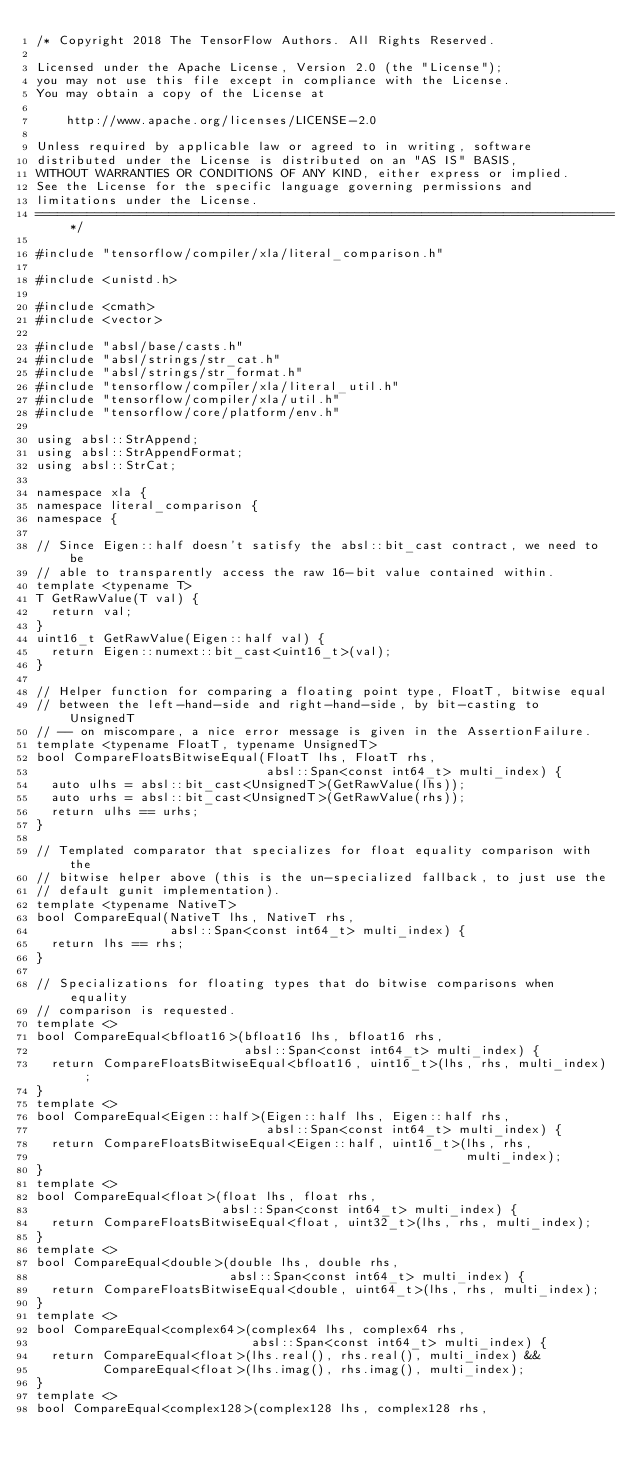<code> <loc_0><loc_0><loc_500><loc_500><_C++_>/* Copyright 2018 The TensorFlow Authors. All Rights Reserved.

Licensed under the Apache License, Version 2.0 (the "License");
you may not use this file except in compliance with the License.
You may obtain a copy of the License at

    http://www.apache.org/licenses/LICENSE-2.0

Unless required by applicable law or agreed to in writing, software
distributed under the License is distributed on an "AS IS" BASIS,
WITHOUT WARRANTIES OR CONDITIONS OF ANY KIND, either express or implied.
See the License for the specific language governing permissions and
limitations under the License.
==============================================================================*/

#include "tensorflow/compiler/xla/literal_comparison.h"

#include <unistd.h>

#include <cmath>
#include <vector>

#include "absl/base/casts.h"
#include "absl/strings/str_cat.h"
#include "absl/strings/str_format.h"
#include "tensorflow/compiler/xla/literal_util.h"
#include "tensorflow/compiler/xla/util.h"
#include "tensorflow/core/platform/env.h"

using absl::StrAppend;
using absl::StrAppendFormat;
using absl::StrCat;

namespace xla {
namespace literal_comparison {
namespace {

// Since Eigen::half doesn't satisfy the absl::bit_cast contract, we need to be
// able to transparently access the raw 16-bit value contained within.
template <typename T>
T GetRawValue(T val) {
  return val;
}
uint16_t GetRawValue(Eigen::half val) {
  return Eigen::numext::bit_cast<uint16_t>(val);
}

// Helper function for comparing a floating point type, FloatT, bitwise equal
// between the left-hand-side and right-hand-side, by bit-casting to UnsignedT
// -- on miscompare, a nice error message is given in the AssertionFailure.
template <typename FloatT, typename UnsignedT>
bool CompareFloatsBitwiseEqual(FloatT lhs, FloatT rhs,
                               absl::Span<const int64_t> multi_index) {
  auto ulhs = absl::bit_cast<UnsignedT>(GetRawValue(lhs));
  auto urhs = absl::bit_cast<UnsignedT>(GetRawValue(rhs));
  return ulhs == urhs;
}

// Templated comparator that specializes for float equality comparison with the
// bitwise helper above (this is the un-specialized fallback, to just use the
// default gunit implementation).
template <typename NativeT>
bool CompareEqual(NativeT lhs, NativeT rhs,
                  absl::Span<const int64_t> multi_index) {
  return lhs == rhs;
}

// Specializations for floating types that do bitwise comparisons when equality
// comparison is requested.
template <>
bool CompareEqual<bfloat16>(bfloat16 lhs, bfloat16 rhs,
                            absl::Span<const int64_t> multi_index) {
  return CompareFloatsBitwiseEqual<bfloat16, uint16_t>(lhs, rhs, multi_index);
}
template <>
bool CompareEqual<Eigen::half>(Eigen::half lhs, Eigen::half rhs,
                               absl::Span<const int64_t> multi_index) {
  return CompareFloatsBitwiseEqual<Eigen::half, uint16_t>(lhs, rhs,
                                                          multi_index);
}
template <>
bool CompareEqual<float>(float lhs, float rhs,
                         absl::Span<const int64_t> multi_index) {
  return CompareFloatsBitwiseEqual<float, uint32_t>(lhs, rhs, multi_index);
}
template <>
bool CompareEqual<double>(double lhs, double rhs,
                          absl::Span<const int64_t> multi_index) {
  return CompareFloatsBitwiseEqual<double, uint64_t>(lhs, rhs, multi_index);
}
template <>
bool CompareEqual<complex64>(complex64 lhs, complex64 rhs,
                             absl::Span<const int64_t> multi_index) {
  return CompareEqual<float>(lhs.real(), rhs.real(), multi_index) &&
         CompareEqual<float>(lhs.imag(), rhs.imag(), multi_index);
}
template <>
bool CompareEqual<complex128>(complex128 lhs, complex128 rhs,</code> 